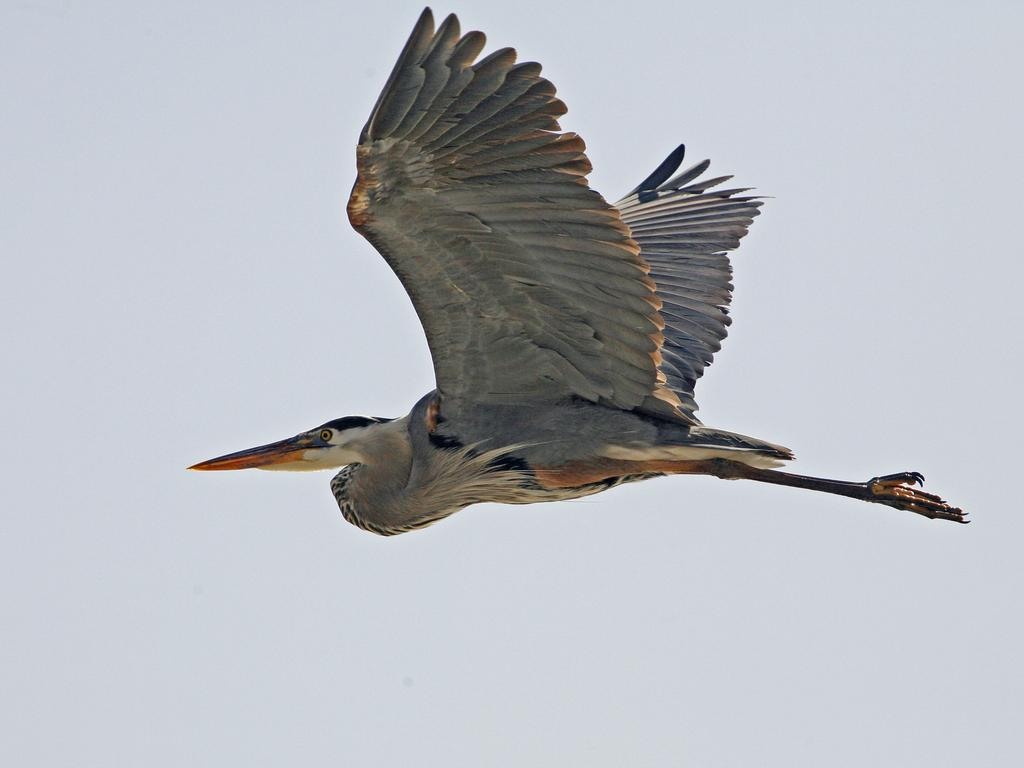What is the main subject in the foreground of the image? There is a bird in the foreground of the image. What is the bird doing in the image? The bird is flying in the air. What can be seen in the background of the image? The sky is visible in the background of the image. When was the image taken? The image was taken during the day. What type of beds can be seen in the image? There are no beds present in the image; it features a bird flying in the air. What activity is the bird participating in during the event in the image? The image does not depict an event, and the bird is simply flying in the air. 